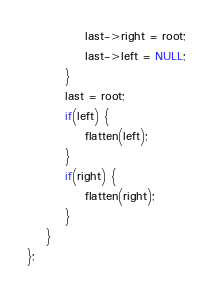<code> <loc_0><loc_0><loc_500><loc_500><_C++_>            last->right = root;
            last->left = NULL;
        }
        last = root;
        if(left) {
            flatten(left);
        }
        if(right) {
            flatten(right);
        }
    }
};
</code> 